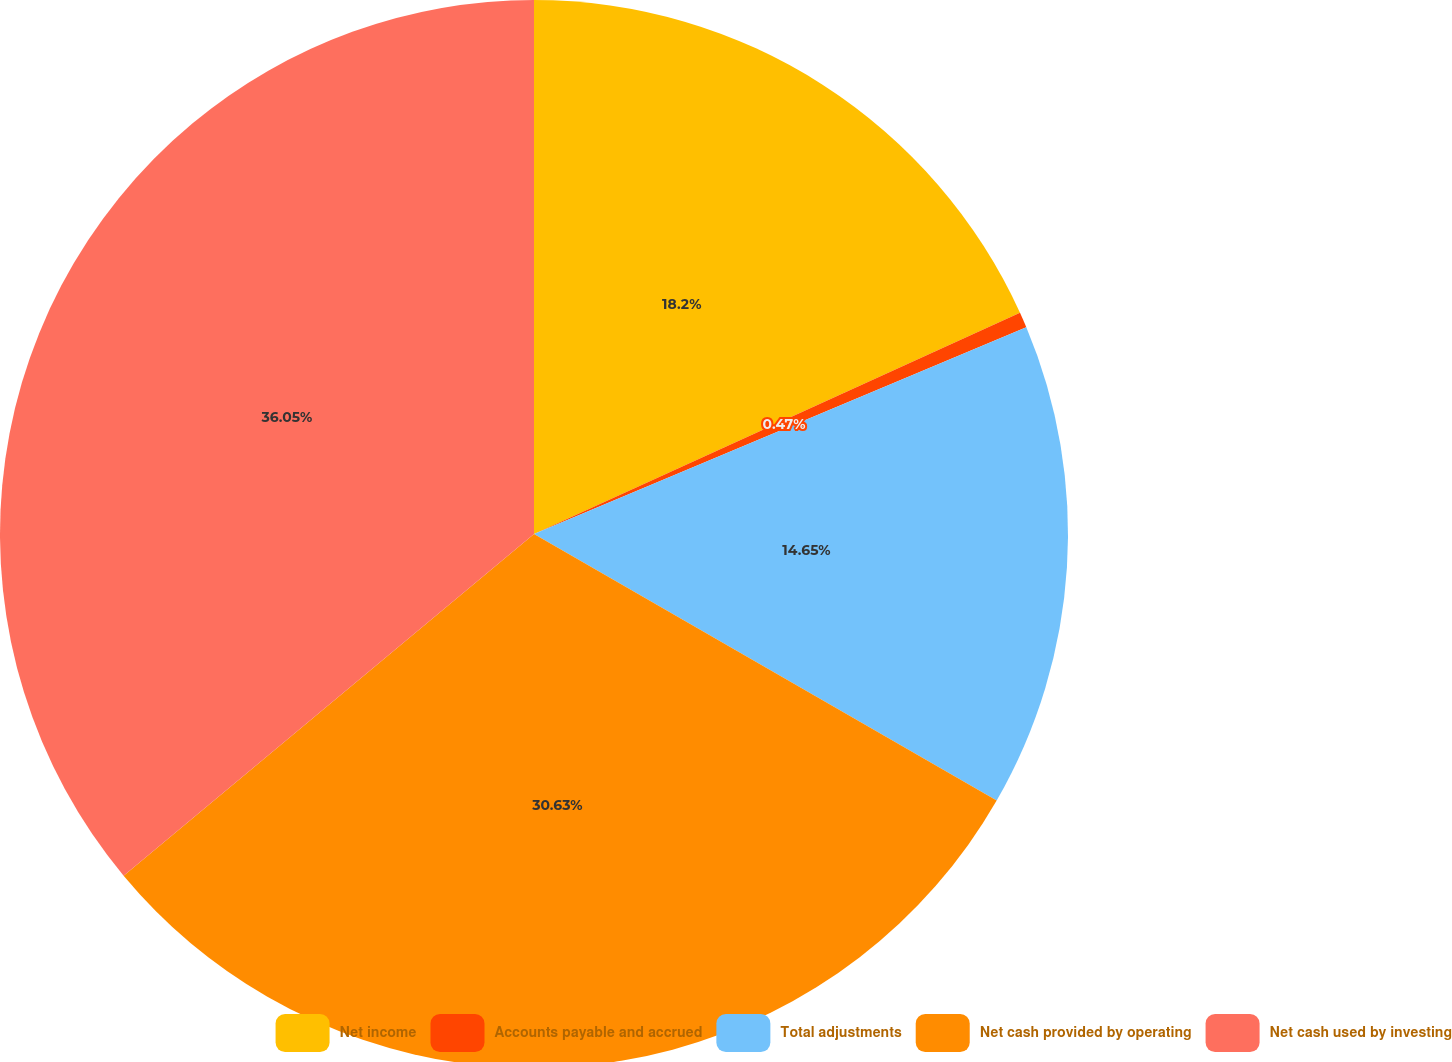<chart> <loc_0><loc_0><loc_500><loc_500><pie_chart><fcel>Net income<fcel>Accounts payable and accrued<fcel>Total adjustments<fcel>Net cash provided by operating<fcel>Net cash used by investing<nl><fcel>18.2%<fcel>0.47%<fcel>14.65%<fcel>30.63%<fcel>36.05%<nl></chart> 